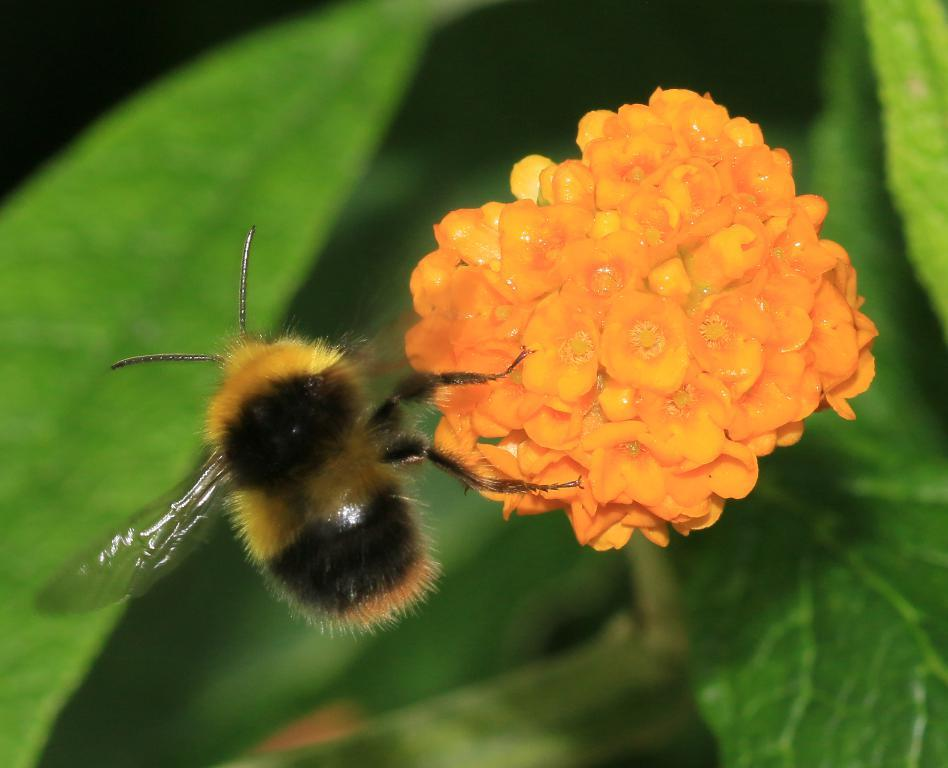What is the main subject of the image? There is a flower in the image. What color is the flower? The flower is orange in color. Are there any other living organisms in the image? Yes, there is a honey bee in the image. What can be seen in the background of the image? There are leaves in the background of the image. What type of plantation can be seen in the image? There is no plantation present in the image; it features a single orange flower and a honey bee. Can you tell me how many pieces of quartz are visible in the image? There is no quartz present in the image. 